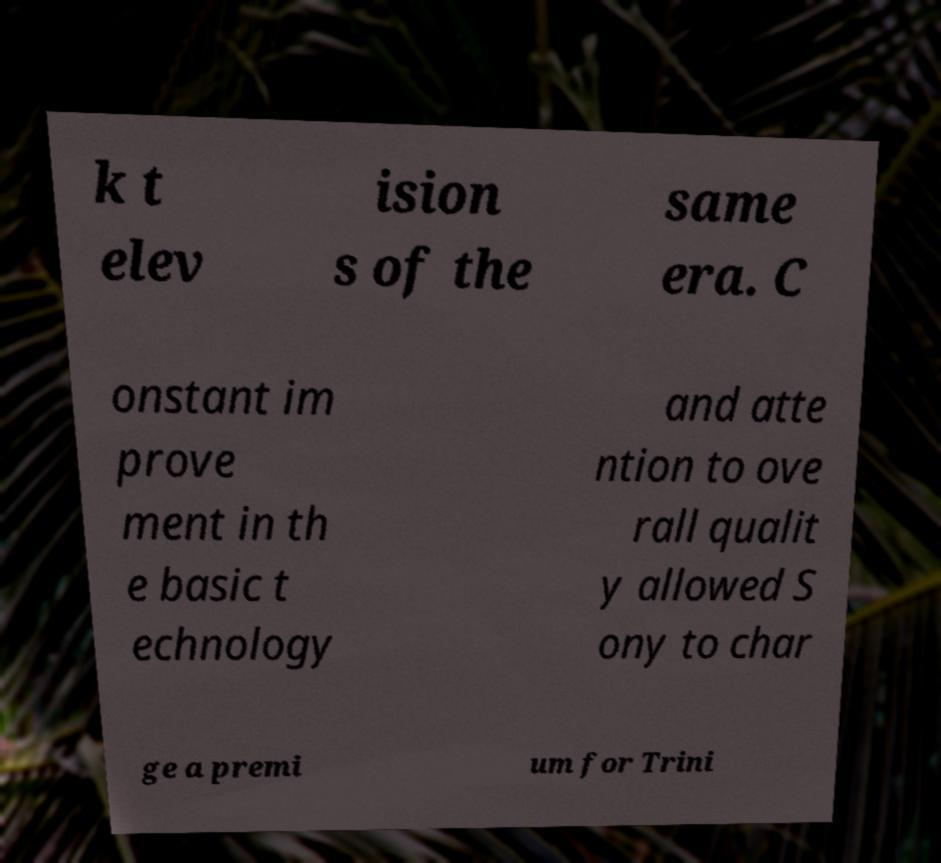I need the written content from this picture converted into text. Can you do that? k t elev ision s of the same era. C onstant im prove ment in th e basic t echnology and atte ntion to ove rall qualit y allowed S ony to char ge a premi um for Trini 